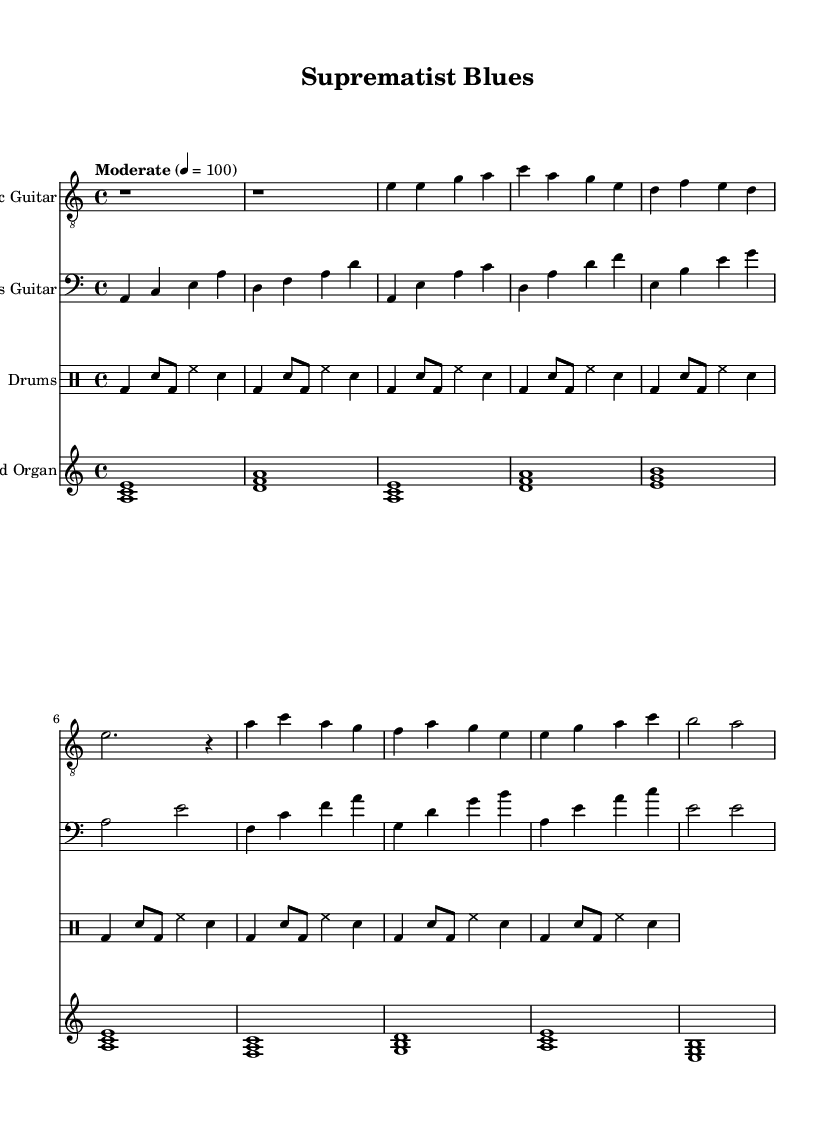What is the key signature of this music? The key signature is A minor, which contains no sharps or flats. A minor is considered the relative minor of C major.
Answer: A minor What is the time signature of this piece? The time signature is 4/4, indicated at the beginning of the sheet music, meaning there are four beats in each measure.
Answer: 4/4 What is the tempo marking for this composition? The tempo marking is "Moderate" at a speed of quarter note = 100 beats per minute, suggesting a moderate pace for the piece.
Answer: Moderate 4 = 100 How many measures are in the verse section? The verse section consists of four measures, as indicated in the sheet music, where the electric guitar and other instruments play established patterns.
Answer: 4 In which clef is the electric guitar part notated? The electric guitar part is notated in the treble clef, which is appropriate for higher-pitched instruments like the guitar.
Answer: Treble clef What type of section follows the intro in this composition? The section following the intro is called the verse, where specific musical phrases are introduced and played.
Answer: Verse What instruments are featured in this electric blues piece? The featured instruments include Electric Guitar, Bass Guitar, Drums, and Hammond Organ, as specified in the different staves of the sheet music.
Answer: Electric Guitar, Bass Guitar, Drums, Hammond Organ 